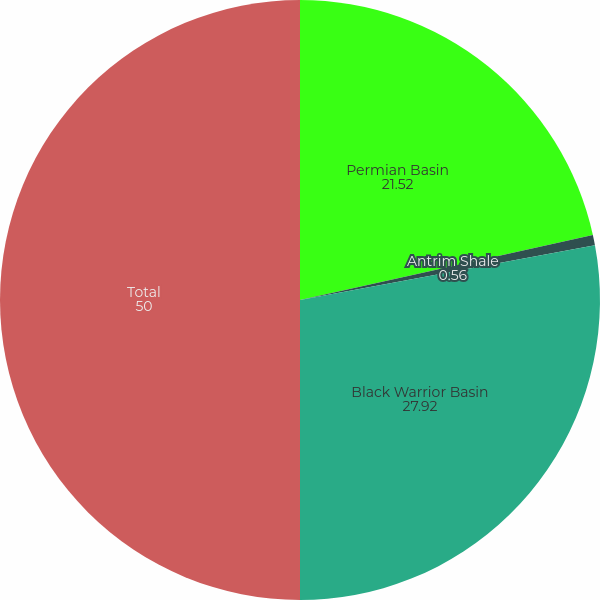<chart> <loc_0><loc_0><loc_500><loc_500><pie_chart><fcel>Permian Basin<fcel>Antrim Shale<fcel>Black Warrior Basin<fcel>Total<nl><fcel>21.52%<fcel>0.56%<fcel>27.92%<fcel>50.0%<nl></chart> 